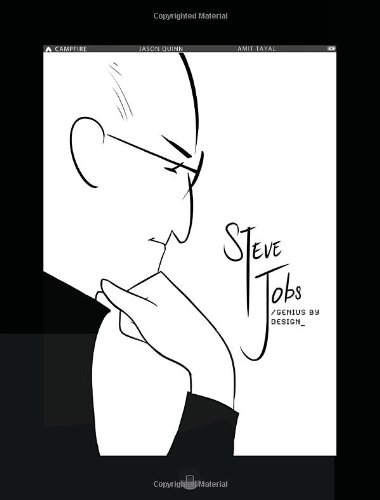How does this book portray the innovations of Steve Jobs? The book explores Steve Jobs' innovative spirit through a series of transformative events and key product developments. Graphic panels detail his creative process and the impact of his vision on technology and culture. 